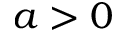<formula> <loc_0><loc_0><loc_500><loc_500>a > 0</formula> 